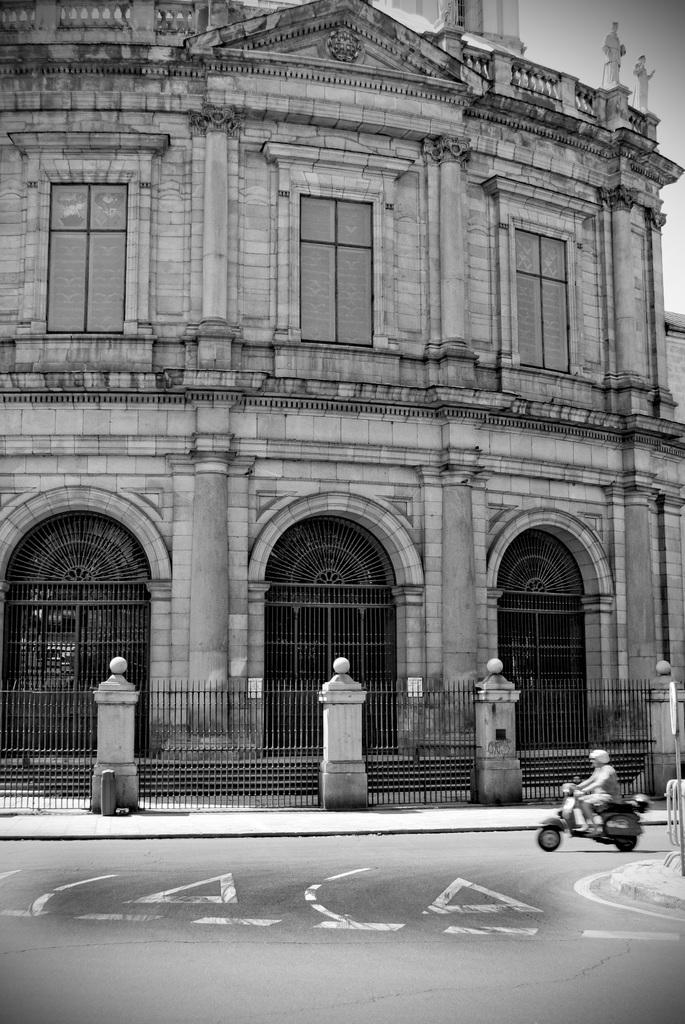What type of structure is visible in the image? There is a building in the image. What is located near the building? There is a fence in the image. What is the person in the image doing? A person is sitting on a vehicle in the image. What can be seen on the right side of the image? There are objects on the right side of the image. What is visible in the background of the image? The sky is visible in the image. What is the color scheme of the image? The image is black and white in color. How many ladybugs are crawling on the fence in the image? There are no ladybugs present in the image; it only features a building, a fence, a person sitting on a vehicle, objects on the right side, the sky, and a black and white color scheme. What type of cheese is the governor eating in the image? There is no governor or cheese present in the image. 